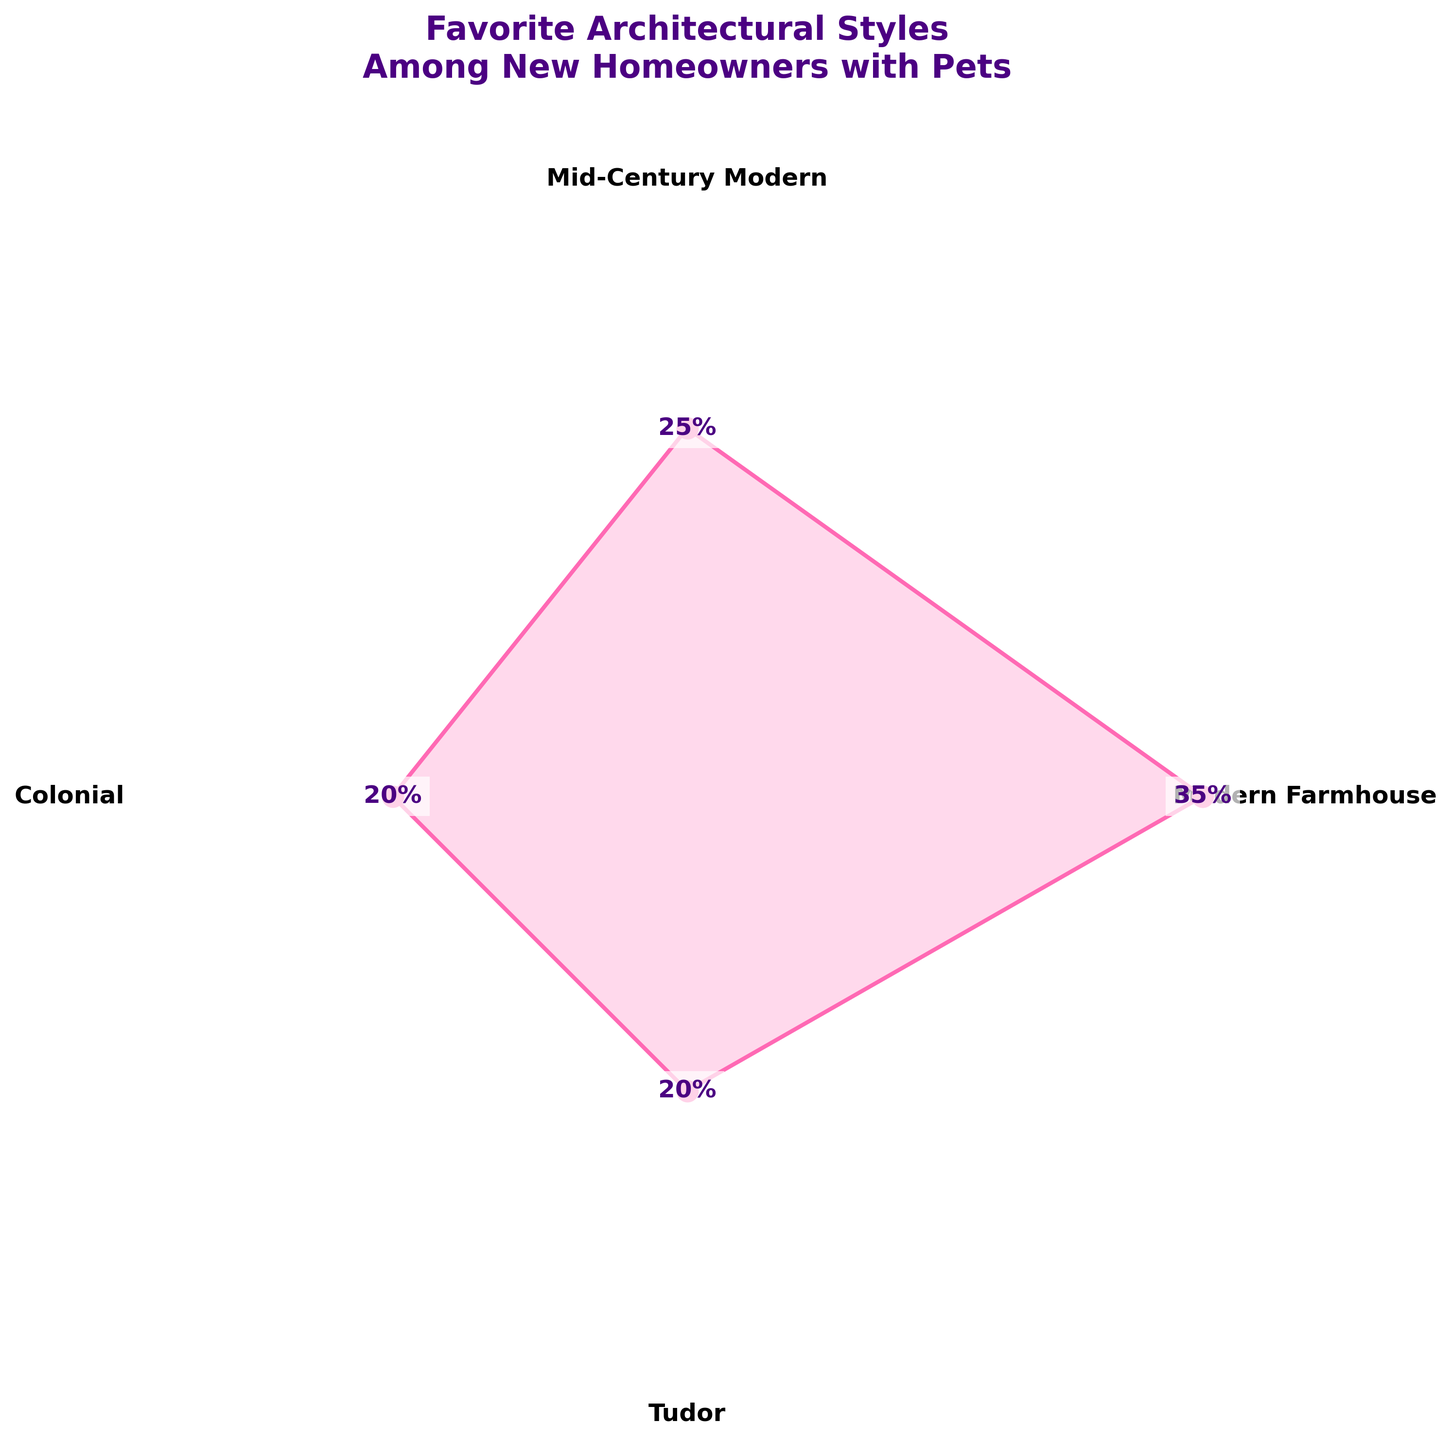Which architectural style is the most popular among new homeowners with pets? The style with the highest percentage is the most popular. The figure shows "Modern Farmhouse" with the highest mark on the scale.
Answer: Modern Farmhouse What is the least popular architectural style among the new homeowners with pets? The least popular styles will have the lowest equal points on the radial chart. From the chart, "Colonial" and "Tudor" both show the lowest percentages.
Answer: Colonial, Tudor How many architectural styles are shown in the chart? By counting the number of sectioned labels around the radial axis, we can see there are four styles listed.
Answer: Four What is the combined percentage of homeowners preferring either Colonial or Tudor styles? Add the percentages of Colonial and Tudor. 20% (Colonial) + 20% (Tudor) = 40%.
Answer: 40% Which architectural style is second most popular and by what percentage? The second highest percentage after the most popular signifies the second most popular style. "Mid-Century Modern" ranks second with 25%.
Answer: Mid-Century Modern, 25% What is the difference in popularity between Modern Farmhouse and the next most popular style? Subtract the percentage of Mid-Century Modern from Modern Farmhouse. 35% - 25% = 10%.
Answer: 10% How does the popularity of Colonial and Tudor styles compare with Modern Farmhouse? Combined, Colonial and Tudor make up 40% (20% + 20%), which is still more than Modern Farmhouse which is 35%.
Answer: 5% more Which styles have equal popularity? When looking at the chart, both Colonial and Tudor sections extend to the same radial distance, indicating they have equal percentages.
Answer: Colonial, Tudor Is there any style that has less than 25% preference among homeowners? Any style marker on the chart displaying less than the 25% radial mark qualifies. Both "Colonial" and "Tudor" under 20% are below 25%.
Answer: Yes, Colonial and Tudor 